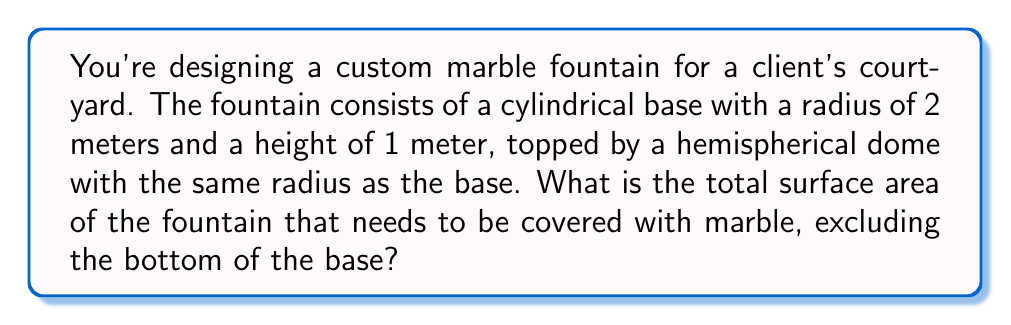Can you solve this math problem? Let's break this down step-by-step:

1) First, let's calculate the surface area of the cylindrical base:
   - Lateral surface area of cylinder = $2\pi rh$
   - $r = 2$ m, $h = 1$ m
   - Lateral surface area = $2\pi(2)(1) = 4\pi$ m²

2) Now, let's calculate the surface area of the hemispherical dome:
   - Surface area of a hemisphere = $2\pi r^2$
   - $r = 2$ m
   - Hemisphere surface area = $2\pi(2^2) = 8\pi$ m²

3) We also need to include the circular top of the cylindrical base:
   - Area of a circle = $\pi r^2$
   - $r = 2$ m
   - Circle area = $\pi(2^2) = 4\pi$ m²

4) Total surface area is the sum of these three parts:
   $$\text{Total Area} = 4\pi + 8\pi + 4\pi = 16\pi \text{ m}^2$$

5) Simplifying:
   $$16\pi \approx 50.27 \text{ m}^2$$
Answer: $50.27 \text{ m}^2$ 